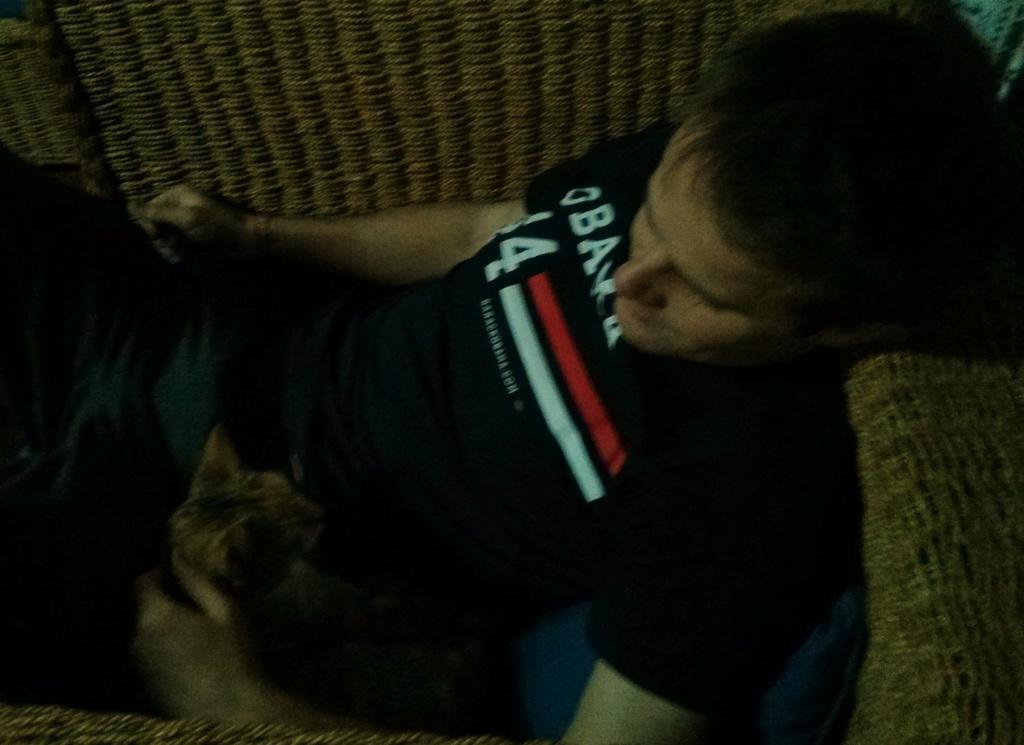In one or two sentences, can you explain what this image depicts? This man wore black t-shirt and laying on this couch. Beside this man there is a cat and he is holding this cat. 